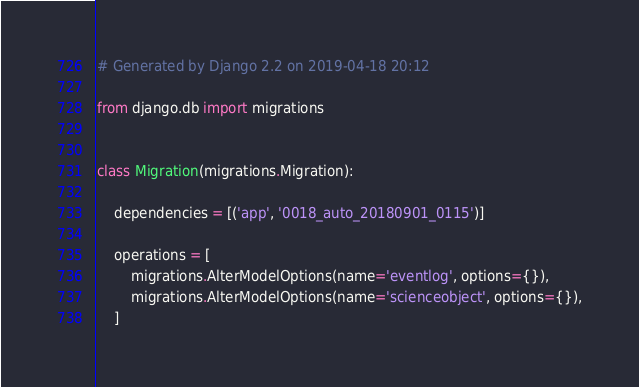Convert code to text. <code><loc_0><loc_0><loc_500><loc_500><_Python_># Generated by Django 2.2 on 2019-04-18 20:12

from django.db import migrations


class Migration(migrations.Migration):

    dependencies = [('app', '0018_auto_20180901_0115')]

    operations = [
        migrations.AlterModelOptions(name='eventlog', options={}),
        migrations.AlterModelOptions(name='scienceobject', options={}),
    ]
</code> 